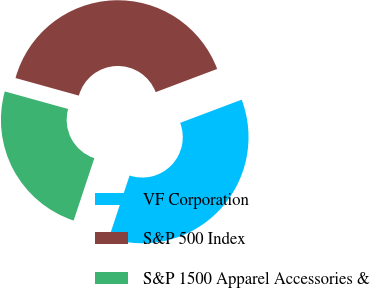Convert chart. <chart><loc_0><loc_0><loc_500><loc_500><pie_chart><fcel>VF Corporation<fcel>S&P 500 Index<fcel>S&P 1500 Apparel Accessories &<nl><fcel>35.84%<fcel>39.95%<fcel>24.2%<nl></chart> 